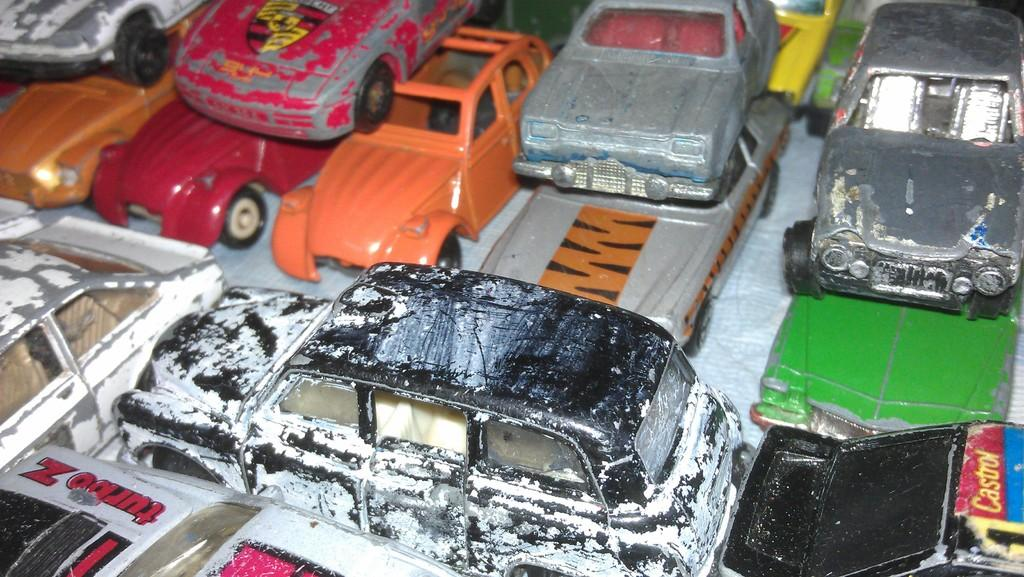What type of objects are in the image? There is a group of toy vehicles in the image. Where are the toy vehicles located? The toy vehicles are placed on a surface. Reasoning: Let'g: Let's think step by step in order to produce the conversation. We start by identifying the main subject in the image, which is the group of toy vehicles. Then, we describe the location of the toy vehicles, which is on a surface. Each question is designed to elicit a specific detail about the image that is known from the provided facts. Absurd Question/Answer: What color is the cactus in the image? There is no cactus present in the image. What color is the cactus in the image? There is no cactus present in the image. 